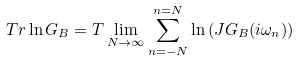<formula> <loc_0><loc_0><loc_500><loc_500>T r \ln G _ { B } = T \lim _ { N \rightarrow \infty } \sum _ { n = - N } ^ { n = N } \ln \left ( { J G _ { B } ( i \omega _ { n } ) } \right )</formula> 